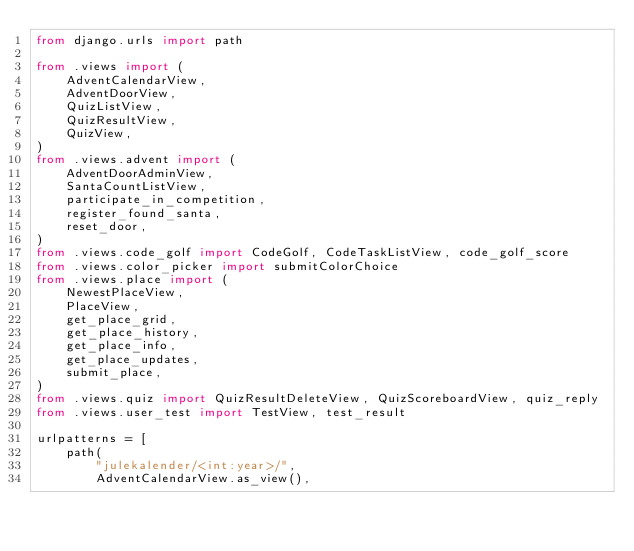<code> <loc_0><loc_0><loc_500><loc_500><_Python_>from django.urls import path

from .views import (
    AdventCalendarView,
    AdventDoorView,
    QuizListView,
    QuizResultView,
    QuizView,
)
from .views.advent import (
    AdventDoorAdminView,
    SantaCountListView,
    participate_in_competition,
    register_found_santa,
    reset_door,
)
from .views.code_golf import CodeGolf, CodeTaskListView, code_golf_score
from .views.color_picker import submitColorChoice
from .views.place import (
    NewestPlaceView,
    PlaceView,
    get_place_grid,
    get_place_history,
    get_place_info,
    get_place_updates,
    submit_place,
)
from .views.quiz import QuizResultDeleteView, QuizScoreboardView, quiz_reply
from .views.user_test import TestView, test_result

urlpatterns = [
    path(
        "julekalender/<int:year>/",
        AdventCalendarView.as_view(),</code> 